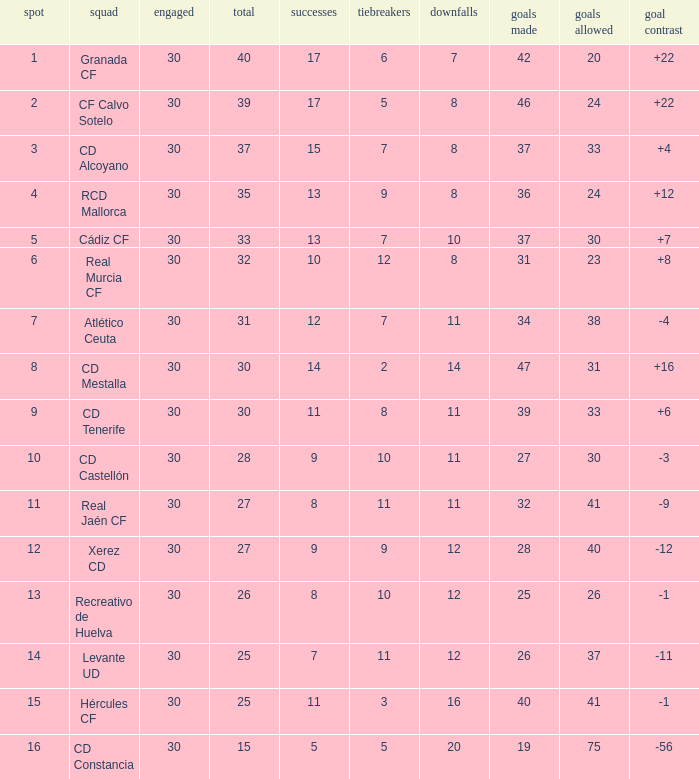Which Wins have a Goal Difference larger than 12, and a Club of granada cf, and Played larger than 30? None. 